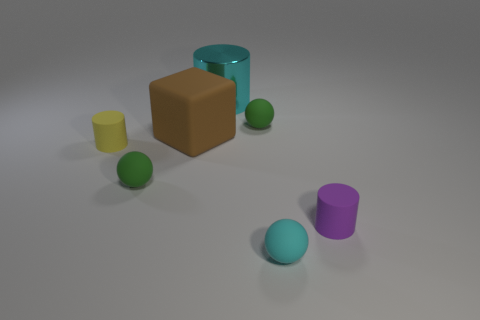What number of things are cubes or things that are on the right side of the brown block?
Keep it short and to the point. 5. Is there a cyan ball that has the same material as the large block?
Offer a terse response. Yes. What number of tiny cylinders are both to the left of the cyan sphere and on the right side of the cyan cylinder?
Provide a succinct answer. 0. What is the material of the cyan object that is to the left of the small cyan matte sphere?
Provide a short and direct response. Metal. The purple cylinder that is the same material as the tiny cyan sphere is what size?
Your answer should be compact. Small. There is a large matte object; are there any small green objects on the right side of it?
Provide a succinct answer. Yes. What size is the cyan thing that is the same shape as the tiny yellow matte object?
Give a very brief answer. Large. Is the color of the large metal thing the same as the rubber sphere that is in front of the purple thing?
Your response must be concise. Yes. Is the number of brown metallic objects less than the number of big metallic things?
Ensure brevity in your answer.  Yes. How many other objects are the same color as the large matte thing?
Make the answer very short. 0. 